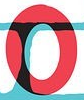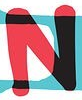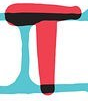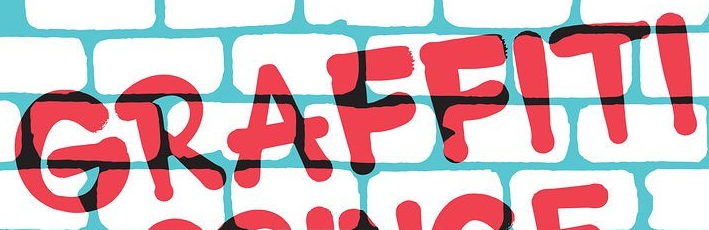What words are shown in these images in order, separated by a semicolon? O; N; T; GRAFFITI 